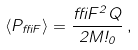Convert formula to latex. <formula><loc_0><loc_0><loc_500><loc_500>\langle P _ { \delta F } \rangle = \frac { \delta F ^ { 2 } Q } { 2 M \omega _ { 0 } } \, ,</formula> 